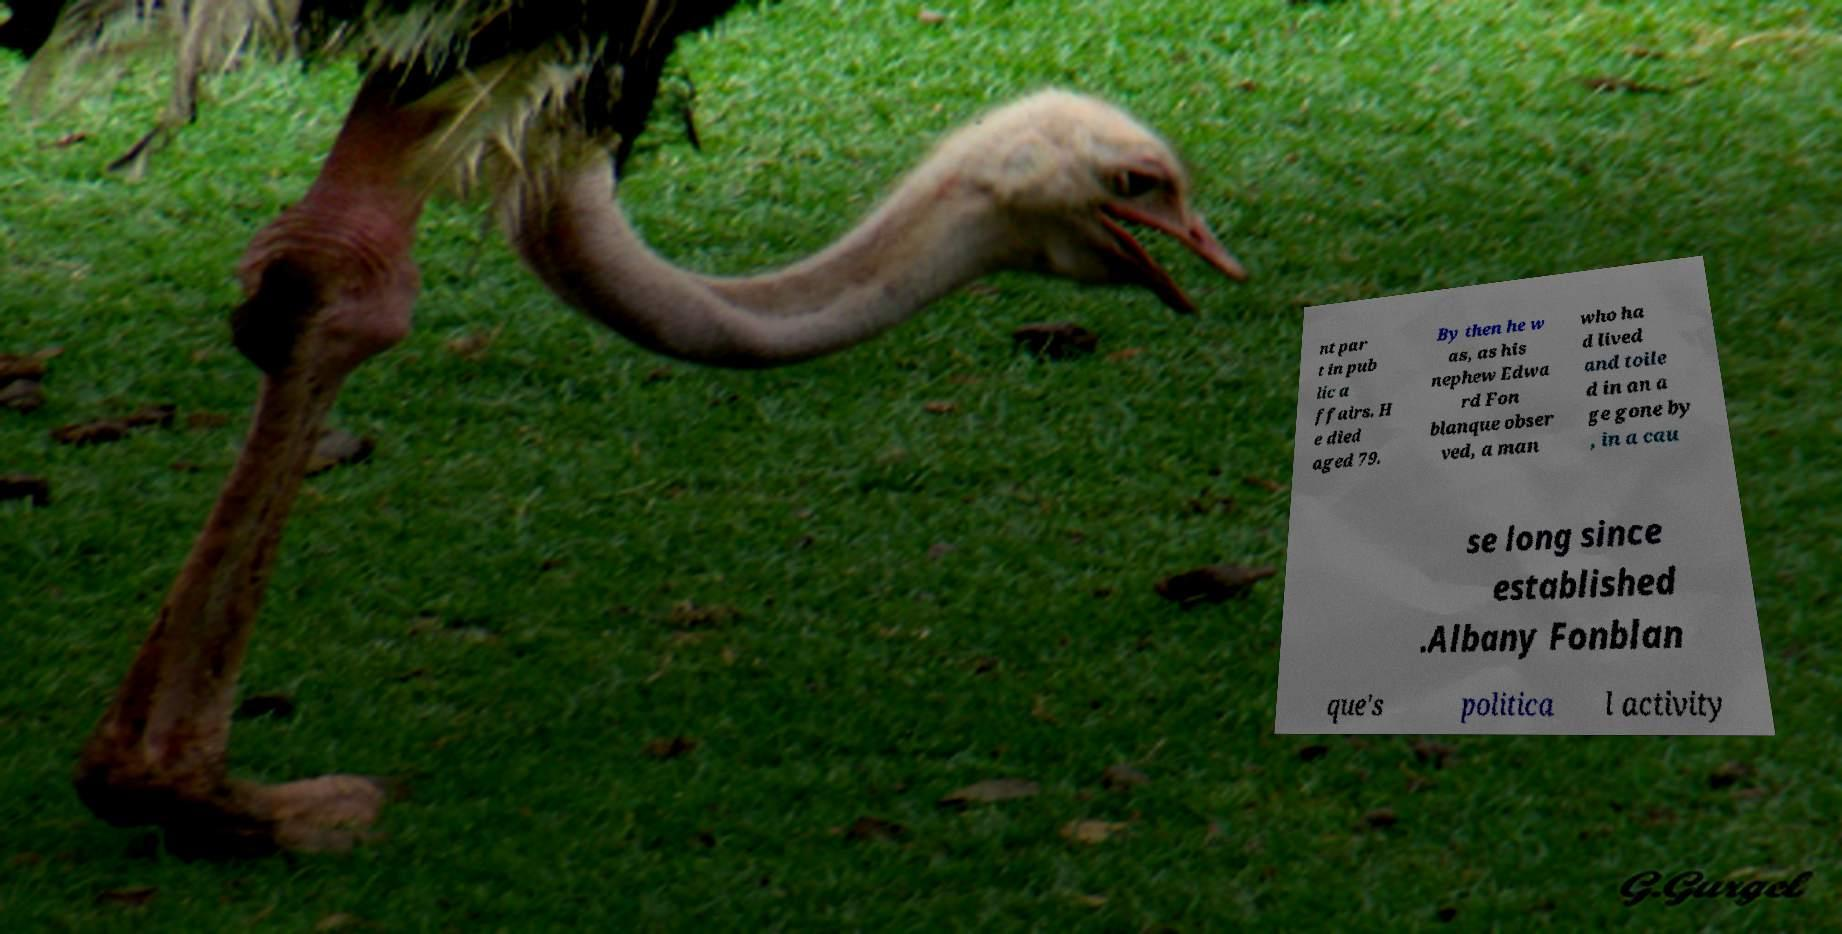I need the written content from this picture converted into text. Can you do that? nt par t in pub lic a ffairs. H e died aged 79. By then he w as, as his nephew Edwa rd Fon blanque obser ved, a man who ha d lived and toile d in an a ge gone by , in a cau se long since established .Albany Fonblan que's politica l activity 